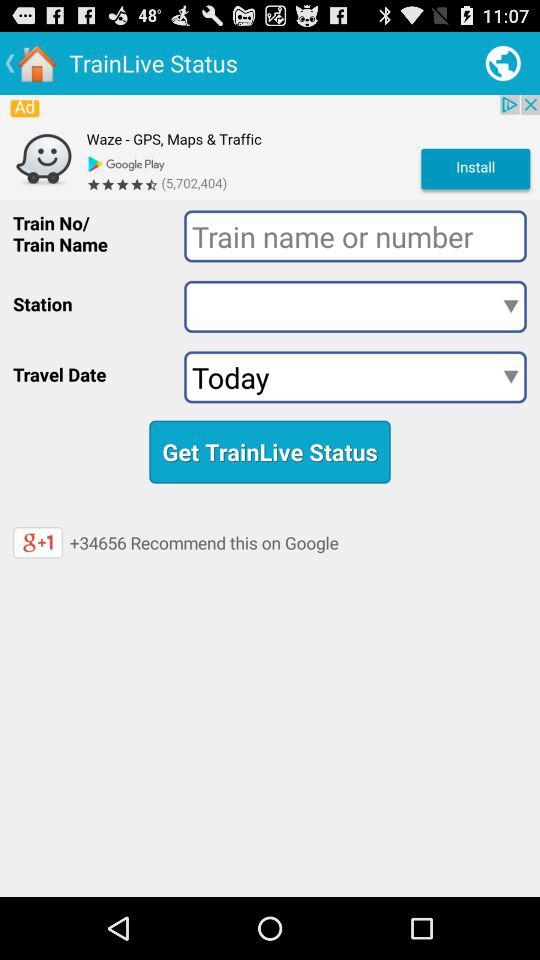What is the travel date?
When the provided information is insufficient, respond with <no answer>. <no answer> 